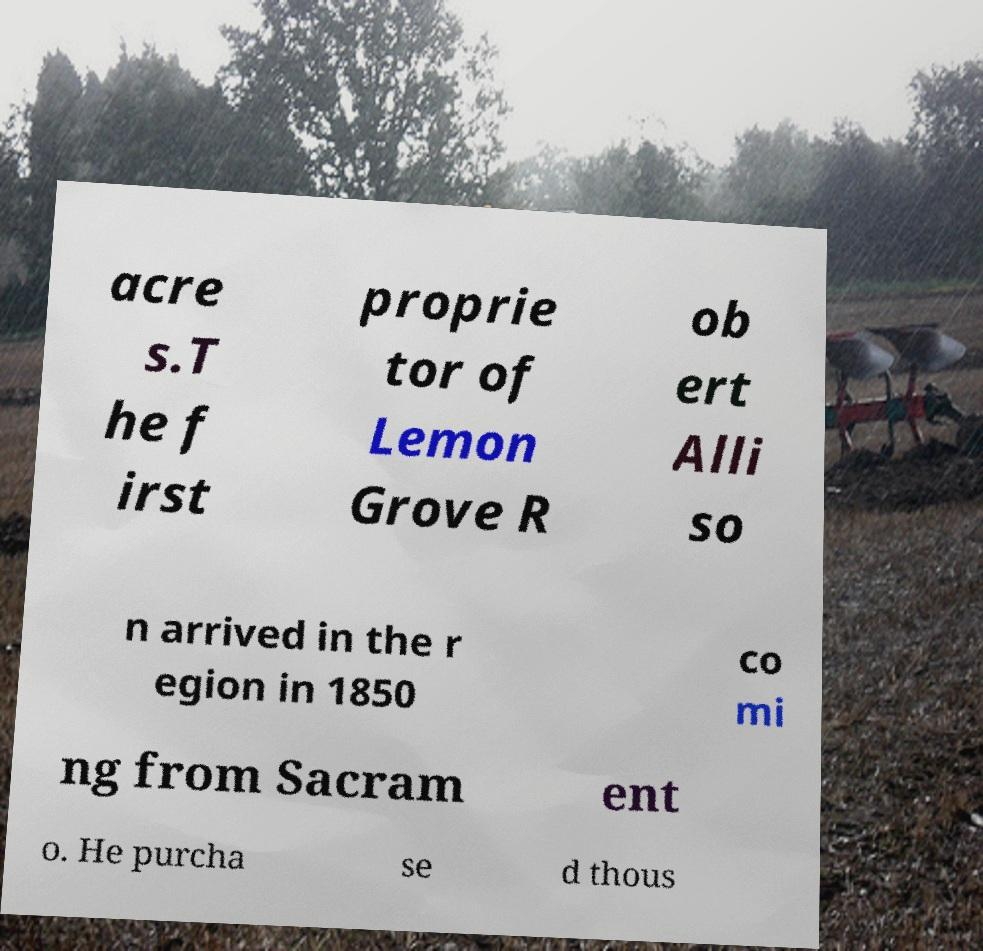Can you read and provide the text displayed in the image?This photo seems to have some interesting text. Can you extract and type it out for me? acre s.T he f irst proprie tor of Lemon Grove R ob ert Alli so n arrived in the r egion in 1850 co mi ng from Sacram ent o. He purcha se d thous 